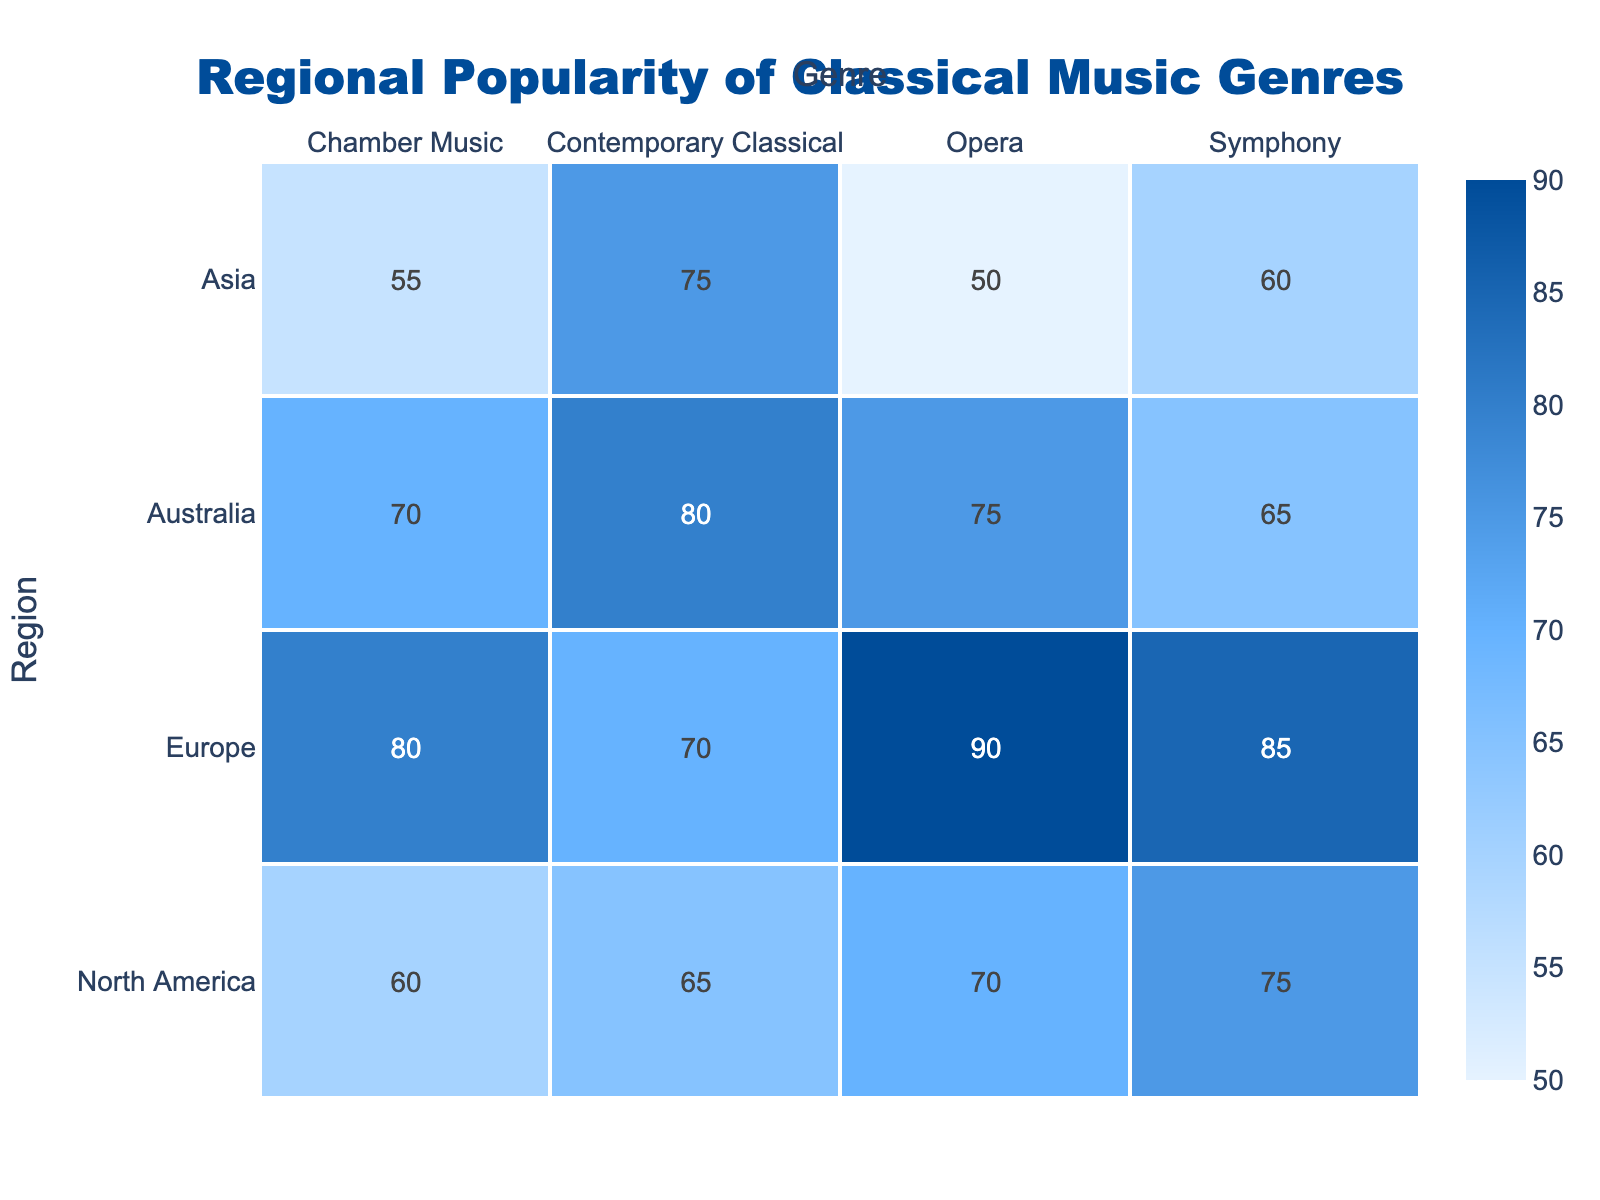What is the highest popularity score for Opera? In the table, we look under the Opera genre across all regions. The scores are 70 for North America, 90 for Europe, 50 for Asia, and 75 for Australia. The highest among these is 90 for Europe.
Answer: 90 Which genre is the least popular in Asia? In the Asia section of the table, we see the popularity scores for the genres: Symphony (60), Chamber Music (55), Opera (50), and Contemporary Classical (75). The lowest score is for Opera at 50.
Answer: Opera What is the average popularity score for Symphony across all regions? The scores for Symphony are 75 (North America), 85 (Europe), 60 (Asia), and 65 (Australia). To find the average: (75 + 85 + 60 + 65) = 285, and there are 4 regions, so 285/4 = 71.25.
Answer: 71.25 Is the popularity of Chamber Music greater than 65 in any region? Checking the Chamber Music scores, we have: 60 in North America, 80 in Europe, 55 in Asia, and 70 in Australia. The only score greater than 65 is in Europe at 80.
Answer: Yes How does the popularity of Contemporary Classical compare between North America and Australia? The scores are 65 for North America and 80 for Australia. To compare, we see that 80 (Australia) is greater than 65 (North America), indicating Contemporary Classical is more popular in Australia.
Answer: Australia is more popular What is the total popularity score for all genres in Europe? The scores for Europe are: Symphony (85), Chamber Music (80), Opera (90), and Contemporary Classical (70). Adding these together gives us 85 + 80 + 90 + 70 = 325.
Answer: 325 Are there any regions where Opera has a popularity score below 60? Looking at the Opera scores: 70 (North America), 90 (Europe), 50 (Asia), and 75 (Australia). Asia has a score of 50, which is indeed below 60.
Answer: Yes Which region has the highest popularity for Chamber Music, and what is the score? In the Chamber Music genre, the scores are: 60 (North America), 80 (Europe), 55 (Asia), and 70 (Australia). The highest score is 80 for Europe.
Answer: Europe, 80 What is the difference in popularity scores for Opera between Europe and Asia? The scores for Opera are 90 in Europe and 50 in Asia. The difference is calculated as 90 - 50 = 40.
Answer: 40 